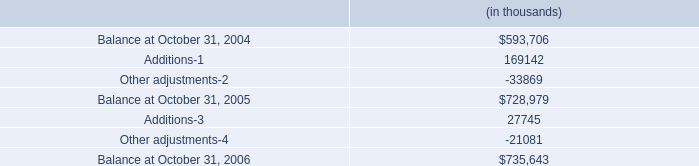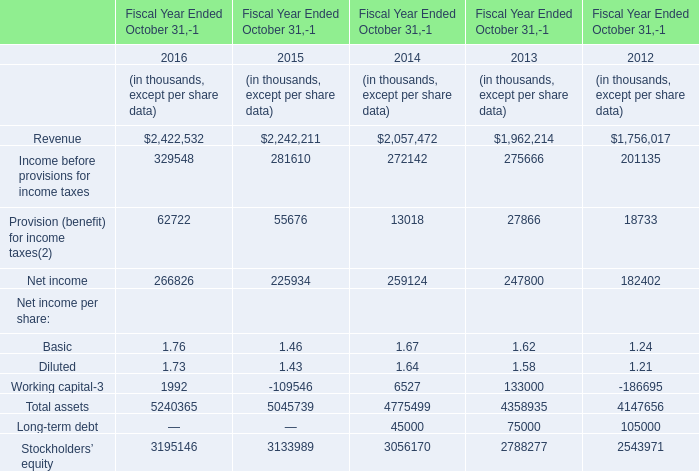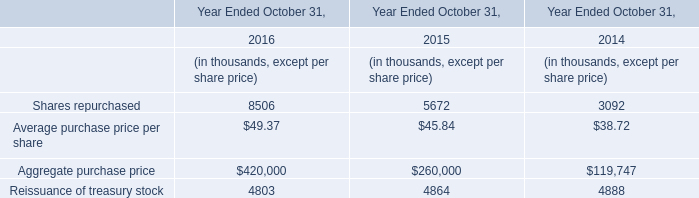What is the average value of Net income in Table 1 and Shares repurchased in Table 2 in 2015? (in thousand) 
Computations: ((225934 + 5672) / 2)
Answer: 115803.0. 